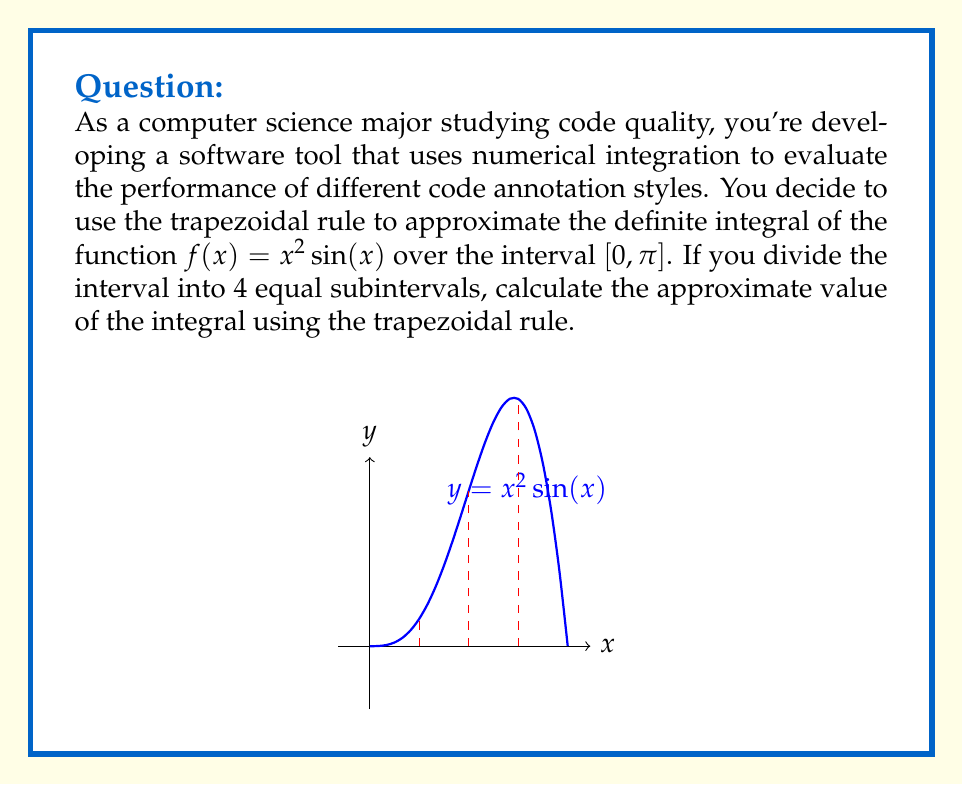Solve this math problem. Let's approach this step-by-step:

1) The trapezoidal rule for n subintervals is given by:

   $$\int_a^b f(x)dx \approx \frac{h}{2}\left[f(x_0) + 2f(x_1) + 2f(x_2) + ... + 2f(x_{n-1}) + f(x_n)\right]$$

   where $h = \frac{b-a}{n}$, and $x_i = a + ih$ for $i = 0, 1, ..., n$

2) In our case, $a=0$, $b=\pi$, $n=4$, and $f(x) = x^2\sin(x)$

3) Calculate $h$:
   $h = \frac{\pi - 0}{4} = \frac{\pi}{4}$

4) Calculate the x-values:
   $x_0 = 0$
   $x_1 = \frac{\pi}{4}$
   $x_2 = \frac{\pi}{2}$
   $x_3 = \frac{3\pi}{4}$
   $x_4 = \pi$

5) Calculate the function values:
   $f(x_0) = f(0) = 0$
   $f(x_1) = f(\frac{\pi}{4}) = (\frac{\pi}{4})^2 \sin(\frac{\pi}{4}) = \frac{\pi^2}{32}\sqrt{2}$
   $f(x_2) = f(\frac{\pi}{2}) = (\frac{\pi}{2})^2 \sin(\frac{\pi}{2}) = \frac{\pi^2}{4}$
   $f(x_3) = f(\frac{3\pi}{4}) = (\frac{3\pi}{4})^2 \sin(\frac{3\pi}{4}) = \frac{9\pi^2}{32}\sqrt{2}$
   $f(x_4) = f(\pi) = \pi^2 \sin(\pi) = 0$

6) Apply the trapezoidal rule:

   $$\int_0^\pi x^2\sin(x)dx \approx \frac{\pi}{8}\left[0 + 2(\frac{\pi^2}{32}\sqrt{2}) + 2(\frac{\pi^2}{4}) + 2(\frac{9\pi^2}{32}\sqrt{2}) + 0\right]$$

7) Simplify:

   $$= \frac{\pi}{8}\left[\frac{\pi^2}{16}\sqrt{2} + \frac{\pi^2}{2} + \frac{9\pi^2}{16}\sqrt{2}\right]$$
   $$= \frac{\pi^3}{128}\left[\sqrt{2} + 8 + 9\sqrt{2}\right]$$
   $$= \frac{\pi^3}{128}\left[10\sqrt{2} + 8\right]$$
Answer: $\frac{\pi^3}{128}(10\sqrt{2} + 8)$ 